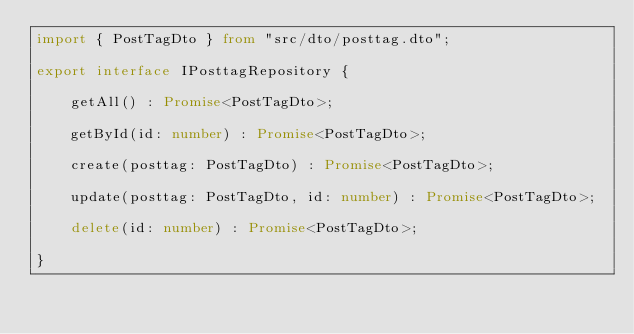Convert code to text. <code><loc_0><loc_0><loc_500><loc_500><_TypeScript_>import { PostTagDto } from "src/dto/posttag.dto";

export interface IPosttagRepository {

    getAll() : Promise<PostTagDto>;

    getById(id: number) : Promise<PostTagDto>;
 
    create(posttag: PostTagDto) : Promise<PostTagDto>;

    update(posttag: PostTagDto, id: number) : Promise<PostTagDto>;

    delete(id: number) : Promise<PostTagDto>;
    
}
</code> 